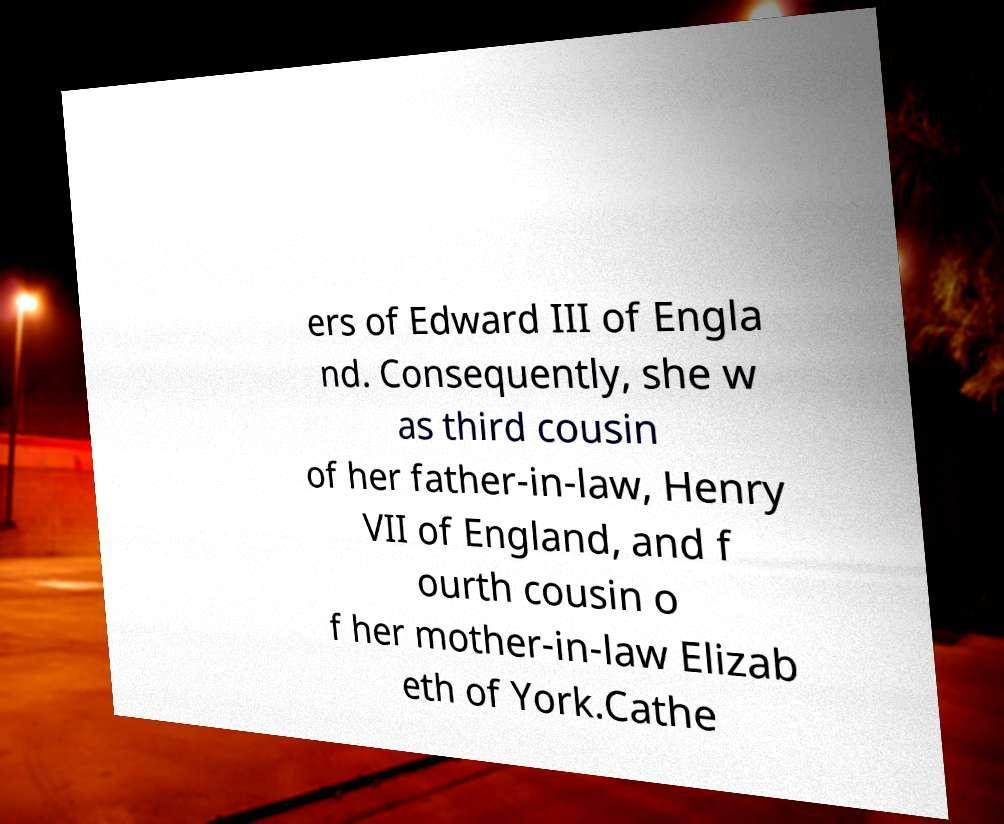Could you assist in decoding the text presented in this image and type it out clearly? ers of Edward III of Engla nd. Consequently, she w as third cousin of her father-in-law, Henry VII of England, and f ourth cousin o f her mother-in-law Elizab eth of York.Cathe 